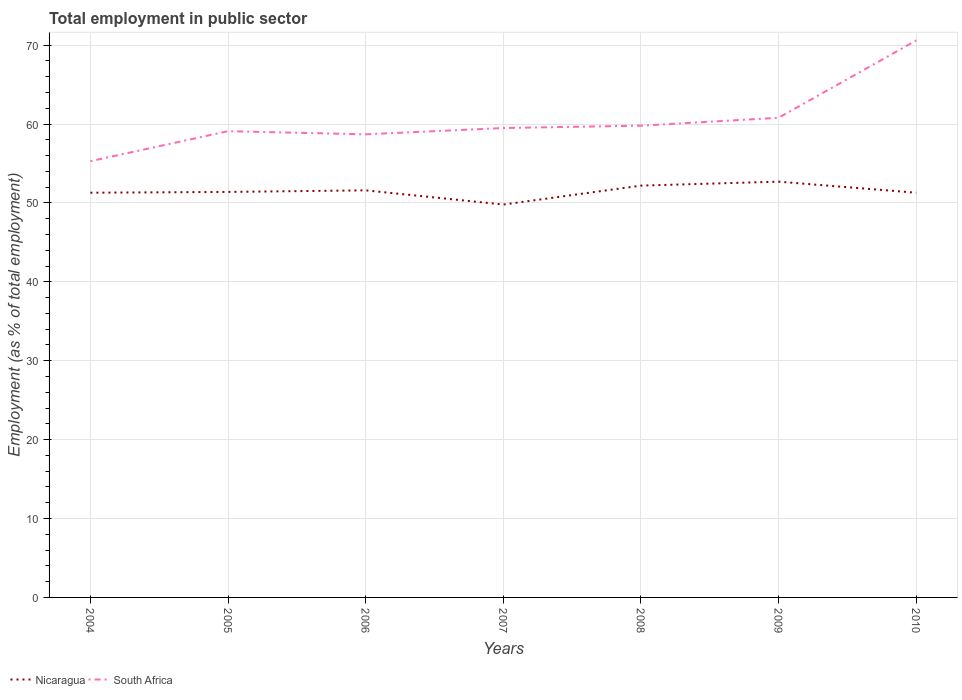Is the number of lines equal to the number of legend labels?
Make the answer very short. Yes. Across all years, what is the maximum employment in public sector in Nicaragua?
Make the answer very short. 49.8. What is the difference between the highest and the second highest employment in public sector in South Africa?
Your answer should be very brief. 15.3. What is the difference between the highest and the lowest employment in public sector in Nicaragua?
Give a very brief answer. 3. Is the employment in public sector in Nicaragua strictly greater than the employment in public sector in South Africa over the years?
Keep it short and to the point. Yes. How many lines are there?
Provide a short and direct response. 2. Does the graph contain any zero values?
Your answer should be compact. No. Does the graph contain grids?
Offer a terse response. Yes. How many legend labels are there?
Your answer should be compact. 2. What is the title of the graph?
Your answer should be very brief. Total employment in public sector. What is the label or title of the Y-axis?
Your answer should be very brief. Employment (as % of total employment). What is the Employment (as % of total employment) of Nicaragua in 2004?
Offer a very short reply. 51.3. What is the Employment (as % of total employment) in South Africa in 2004?
Your response must be concise. 55.3. What is the Employment (as % of total employment) of Nicaragua in 2005?
Your response must be concise. 51.4. What is the Employment (as % of total employment) in South Africa in 2005?
Keep it short and to the point. 59.1. What is the Employment (as % of total employment) of Nicaragua in 2006?
Your answer should be compact. 51.6. What is the Employment (as % of total employment) in South Africa in 2006?
Your answer should be very brief. 58.7. What is the Employment (as % of total employment) in Nicaragua in 2007?
Make the answer very short. 49.8. What is the Employment (as % of total employment) of South Africa in 2007?
Keep it short and to the point. 59.5. What is the Employment (as % of total employment) of Nicaragua in 2008?
Your answer should be very brief. 52.2. What is the Employment (as % of total employment) in South Africa in 2008?
Your response must be concise. 59.8. What is the Employment (as % of total employment) in Nicaragua in 2009?
Ensure brevity in your answer.  52.7. What is the Employment (as % of total employment) in South Africa in 2009?
Your answer should be compact. 60.8. What is the Employment (as % of total employment) in Nicaragua in 2010?
Give a very brief answer. 51.3. What is the Employment (as % of total employment) in South Africa in 2010?
Your answer should be very brief. 70.6. Across all years, what is the maximum Employment (as % of total employment) in Nicaragua?
Your answer should be very brief. 52.7. Across all years, what is the maximum Employment (as % of total employment) of South Africa?
Provide a short and direct response. 70.6. Across all years, what is the minimum Employment (as % of total employment) in Nicaragua?
Make the answer very short. 49.8. Across all years, what is the minimum Employment (as % of total employment) in South Africa?
Provide a short and direct response. 55.3. What is the total Employment (as % of total employment) in Nicaragua in the graph?
Your answer should be compact. 360.3. What is the total Employment (as % of total employment) in South Africa in the graph?
Keep it short and to the point. 423.8. What is the difference between the Employment (as % of total employment) of Nicaragua in 2004 and that in 2005?
Your response must be concise. -0.1. What is the difference between the Employment (as % of total employment) in Nicaragua in 2004 and that in 2006?
Offer a very short reply. -0.3. What is the difference between the Employment (as % of total employment) of South Africa in 2004 and that in 2008?
Offer a very short reply. -4.5. What is the difference between the Employment (as % of total employment) in Nicaragua in 2004 and that in 2010?
Your answer should be compact. 0. What is the difference between the Employment (as % of total employment) in South Africa in 2004 and that in 2010?
Keep it short and to the point. -15.3. What is the difference between the Employment (as % of total employment) in South Africa in 2005 and that in 2006?
Your answer should be very brief. 0.4. What is the difference between the Employment (as % of total employment) in Nicaragua in 2005 and that in 2008?
Your answer should be compact. -0.8. What is the difference between the Employment (as % of total employment) of Nicaragua in 2005 and that in 2009?
Your answer should be very brief. -1.3. What is the difference between the Employment (as % of total employment) of South Africa in 2005 and that in 2010?
Make the answer very short. -11.5. What is the difference between the Employment (as % of total employment) of Nicaragua in 2006 and that in 2008?
Offer a very short reply. -0.6. What is the difference between the Employment (as % of total employment) of South Africa in 2006 and that in 2010?
Offer a very short reply. -11.9. What is the difference between the Employment (as % of total employment) in South Africa in 2007 and that in 2008?
Give a very brief answer. -0.3. What is the difference between the Employment (as % of total employment) of Nicaragua in 2007 and that in 2009?
Offer a terse response. -2.9. What is the difference between the Employment (as % of total employment) in South Africa in 2007 and that in 2009?
Provide a succinct answer. -1.3. What is the difference between the Employment (as % of total employment) of Nicaragua in 2007 and that in 2010?
Your response must be concise. -1.5. What is the difference between the Employment (as % of total employment) of South Africa in 2007 and that in 2010?
Offer a very short reply. -11.1. What is the difference between the Employment (as % of total employment) of Nicaragua in 2008 and that in 2009?
Provide a succinct answer. -0.5. What is the difference between the Employment (as % of total employment) of South Africa in 2008 and that in 2009?
Provide a short and direct response. -1. What is the difference between the Employment (as % of total employment) in South Africa in 2008 and that in 2010?
Your response must be concise. -10.8. What is the difference between the Employment (as % of total employment) in South Africa in 2009 and that in 2010?
Keep it short and to the point. -9.8. What is the difference between the Employment (as % of total employment) of Nicaragua in 2004 and the Employment (as % of total employment) of South Africa in 2005?
Your answer should be very brief. -7.8. What is the difference between the Employment (as % of total employment) in Nicaragua in 2004 and the Employment (as % of total employment) in South Africa in 2006?
Your response must be concise. -7.4. What is the difference between the Employment (as % of total employment) of Nicaragua in 2004 and the Employment (as % of total employment) of South Africa in 2009?
Your answer should be compact. -9.5. What is the difference between the Employment (as % of total employment) in Nicaragua in 2004 and the Employment (as % of total employment) in South Africa in 2010?
Ensure brevity in your answer.  -19.3. What is the difference between the Employment (as % of total employment) of Nicaragua in 2005 and the Employment (as % of total employment) of South Africa in 2006?
Make the answer very short. -7.3. What is the difference between the Employment (as % of total employment) in Nicaragua in 2005 and the Employment (as % of total employment) in South Africa in 2010?
Give a very brief answer. -19.2. What is the difference between the Employment (as % of total employment) in Nicaragua in 2006 and the Employment (as % of total employment) in South Africa in 2007?
Offer a terse response. -7.9. What is the difference between the Employment (as % of total employment) of Nicaragua in 2006 and the Employment (as % of total employment) of South Africa in 2009?
Make the answer very short. -9.2. What is the difference between the Employment (as % of total employment) of Nicaragua in 2007 and the Employment (as % of total employment) of South Africa in 2009?
Give a very brief answer. -11. What is the difference between the Employment (as % of total employment) in Nicaragua in 2007 and the Employment (as % of total employment) in South Africa in 2010?
Keep it short and to the point. -20.8. What is the difference between the Employment (as % of total employment) of Nicaragua in 2008 and the Employment (as % of total employment) of South Africa in 2010?
Offer a terse response. -18.4. What is the difference between the Employment (as % of total employment) of Nicaragua in 2009 and the Employment (as % of total employment) of South Africa in 2010?
Your answer should be compact. -17.9. What is the average Employment (as % of total employment) of Nicaragua per year?
Ensure brevity in your answer.  51.47. What is the average Employment (as % of total employment) in South Africa per year?
Keep it short and to the point. 60.54. In the year 2004, what is the difference between the Employment (as % of total employment) of Nicaragua and Employment (as % of total employment) of South Africa?
Your response must be concise. -4. In the year 2007, what is the difference between the Employment (as % of total employment) of Nicaragua and Employment (as % of total employment) of South Africa?
Offer a very short reply. -9.7. In the year 2010, what is the difference between the Employment (as % of total employment) of Nicaragua and Employment (as % of total employment) of South Africa?
Your answer should be compact. -19.3. What is the ratio of the Employment (as % of total employment) of South Africa in 2004 to that in 2005?
Ensure brevity in your answer.  0.94. What is the ratio of the Employment (as % of total employment) in South Africa in 2004 to that in 2006?
Provide a succinct answer. 0.94. What is the ratio of the Employment (as % of total employment) in Nicaragua in 2004 to that in 2007?
Give a very brief answer. 1.03. What is the ratio of the Employment (as % of total employment) in South Africa in 2004 to that in 2007?
Give a very brief answer. 0.93. What is the ratio of the Employment (as % of total employment) in Nicaragua in 2004 to that in 2008?
Ensure brevity in your answer.  0.98. What is the ratio of the Employment (as % of total employment) of South Africa in 2004 to that in 2008?
Your answer should be compact. 0.92. What is the ratio of the Employment (as % of total employment) in Nicaragua in 2004 to that in 2009?
Offer a terse response. 0.97. What is the ratio of the Employment (as % of total employment) in South Africa in 2004 to that in 2009?
Your answer should be very brief. 0.91. What is the ratio of the Employment (as % of total employment) of Nicaragua in 2004 to that in 2010?
Your answer should be compact. 1. What is the ratio of the Employment (as % of total employment) in South Africa in 2004 to that in 2010?
Your answer should be compact. 0.78. What is the ratio of the Employment (as % of total employment) in Nicaragua in 2005 to that in 2006?
Offer a very short reply. 1. What is the ratio of the Employment (as % of total employment) in South Africa in 2005 to that in 2006?
Give a very brief answer. 1.01. What is the ratio of the Employment (as % of total employment) of Nicaragua in 2005 to that in 2007?
Offer a terse response. 1.03. What is the ratio of the Employment (as % of total employment) in South Africa in 2005 to that in 2007?
Your answer should be very brief. 0.99. What is the ratio of the Employment (as % of total employment) of Nicaragua in 2005 to that in 2008?
Offer a terse response. 0.98. What is the ratio of the Employment (as % of total employment) in South Africa in 2005 to that in 2008?
Ensure brevity in your answer.  0.99. What is the ratio of the Employment (as % of total employment) of Nicaragua in 2005 to that in 2009?
Your response must be concise. 0.98. What is the ratio of the Employment (as % of total employment) of Nicaragua in 2005 to that in 2010?
Make the answer very short. 1. What is the ratio of the Employment (as % of total employment) in South Africa in 2005 to that in 2010?
Your response must be concise. 0.84. What is the ratio of the Employment (as % of total employment) in Nicaragua in 2006 to that in 2007?
Offer a terse response. 1.04. What is the ratio of the Employment (as % of total employment) of South Africa in 2006 to that in 2007?
Give a very brief answer. 0.99. What is the ratio of the Employment (as % of total employment) in Nicaragua in 2006 to that in 2008?
Keep it short and to the point. 0.99. What is the ratio of the Employment (as % of total employment) in South Africa in 2006 to that in 2008?
Offer a very short reply. 0.98. What is the ratio of the Employment (as % of total employment) in Nicaragua in 2006 to that in 2009?
Give a very brief answer. 0.98. What is the ratio of the Employment (as % of total employment) of South Africa in 2006 to that in 2009?
Offer a terse response. 0.97. What is the ratio of the Employment (as % of total employment) of Nicaragua in 2006 to that in 2010?
Your response must be concise. 1.01. What is the ratio of the Employment (as % of total employment) of South Africa in 2006 to that in 2010?
Ensure brevity in your answer.  0.83. What is the ratio of the Employment (as % of total employment) in Nicaragua in 2007 to that in 2008?
Your answer should be very brief. 0.95. What is the ratio of the Employment (as % of total employment) in South Africa in 2007 to that in 2008?
Ensure brevity in your answer.  0.99. What is the ratio of the Employment (as % of total employment) in Nicaragua in 2007 to that in 2009?
Provide a succinct answer. 0.94. What is the ratio of the Employment (as % of total employment) of South Africa in 2007 to that in 2009?
Make the answer very short. 0.98. What is the ratio of the Employment (as % of total employment) of Nicaragua in 2007 to that in 2010?
Give a very brief answer. 0.97. What is the ratio of the Employment (as % of total employment) in South Africa in 2007 to that in 2010?
Provide a succinct answer. 0.84. What is the ratio of the Employment (as % of total employment) in Nicaragua in 2008 to that in 2009?
Offer a very short reply. 0.99. What is the ratio of the Employment (as % of total employment) in South Africa in 2008 to that in 2009?
Offer a very short reply. 0.98. What is the ratio of the Employment (as % of total employment) of Nicaragua in 2008 to that in 2010?
Your answer should be compact. 1.02. What is the ratio of the Employment (as % of total employment) of South Africa in 2008 to that in 2010?
Offer a terse response. 0.85. What is the ratio of the Employment (as % of total employment) of Nicaragua in 2009 to that in 2010?
Your response must be concise. 1.03. What is the ratio of the Employment (as % of total employment) of South Africa in 2009 to that in 2010?
Your response must be concise. 0.86. What is the difference between the highest and the lowest Employment (as % of total employment) in South Africa?
Make the answer very short. 15.3. 